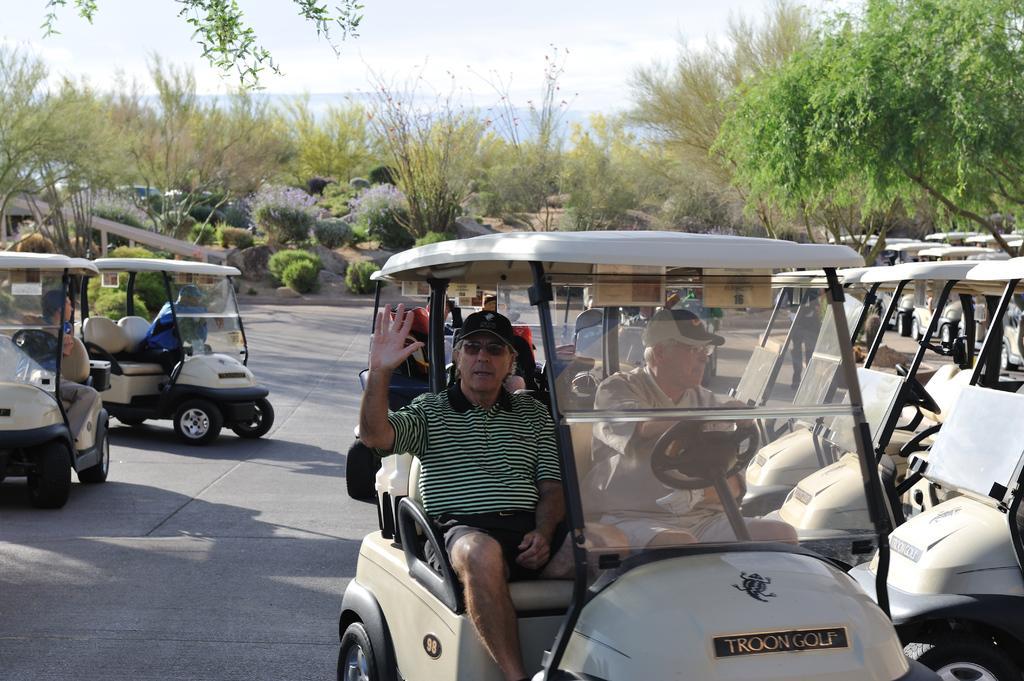Could you give a brief overview of what you see in this image? In the foreground of the picture there are vehicles and road. In the center we can see two persons in the vehicle. In the middle of the picture there are trees, shrubs and soil. On the left we can see hand railing. At the top it is sky. At the top towards left we can see stems of a tree. 